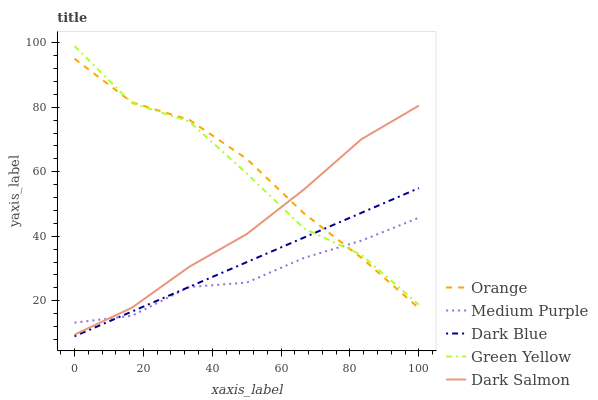Does Green Yellow have the minimum area under the curve?
Answer yes or no. No. Does Green Yellow have the maximum area under the curve?
Answer yes or no. No. Is Medium Purple the smoothest?
Answer yes or no. No. Is Medium Purple the roughest?
Answer yes or no. No. Does Medium Purple have the lowest value?
Answer yes or no. No. Does Medium Purple have the highest value?
Answer yes or no. No. Is Dark Blue less than Dark Salmon?
Answer yes or no. Yes. Is Dark Salmon greater than Dark Blue?
Answer yes or no. Yes. Does Dark Blue intersect Dark Salmon?
Answer yes or no. No. 